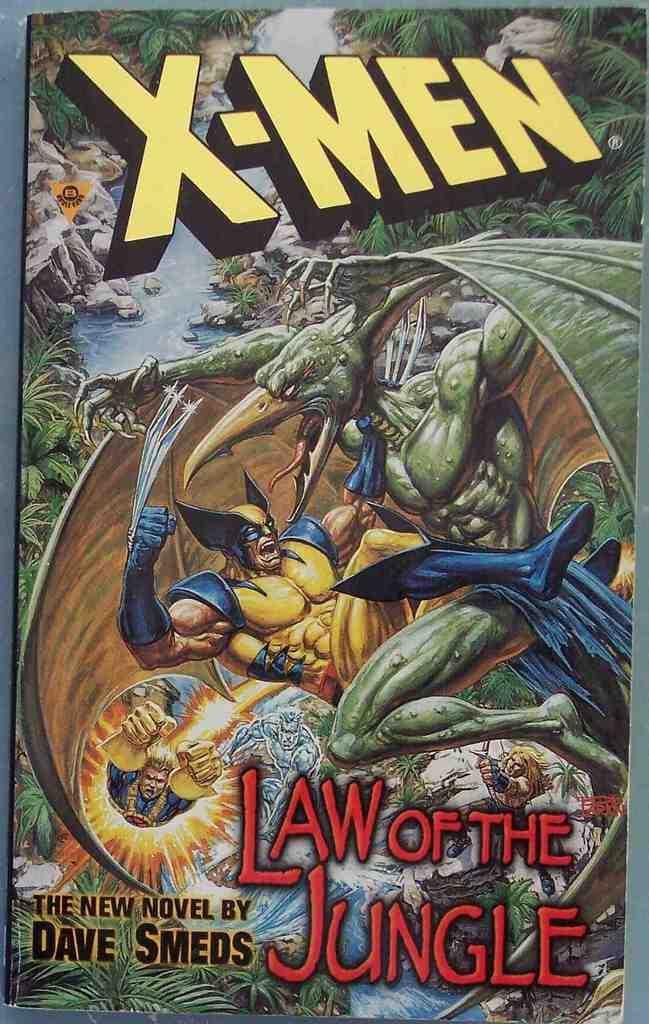What is the main subject of the image? The main subject of the image is a cover page. What images can be seen on the cover page? There is an image of a man and an image of a bird on the cover page. What natural elements are visible in the image? There are rocks, a river, and plants visible in the image. Where is the shelf located in the image? There is no shelf present in the image. How many nails can be seen in the image? There are no nails visible in the image. 